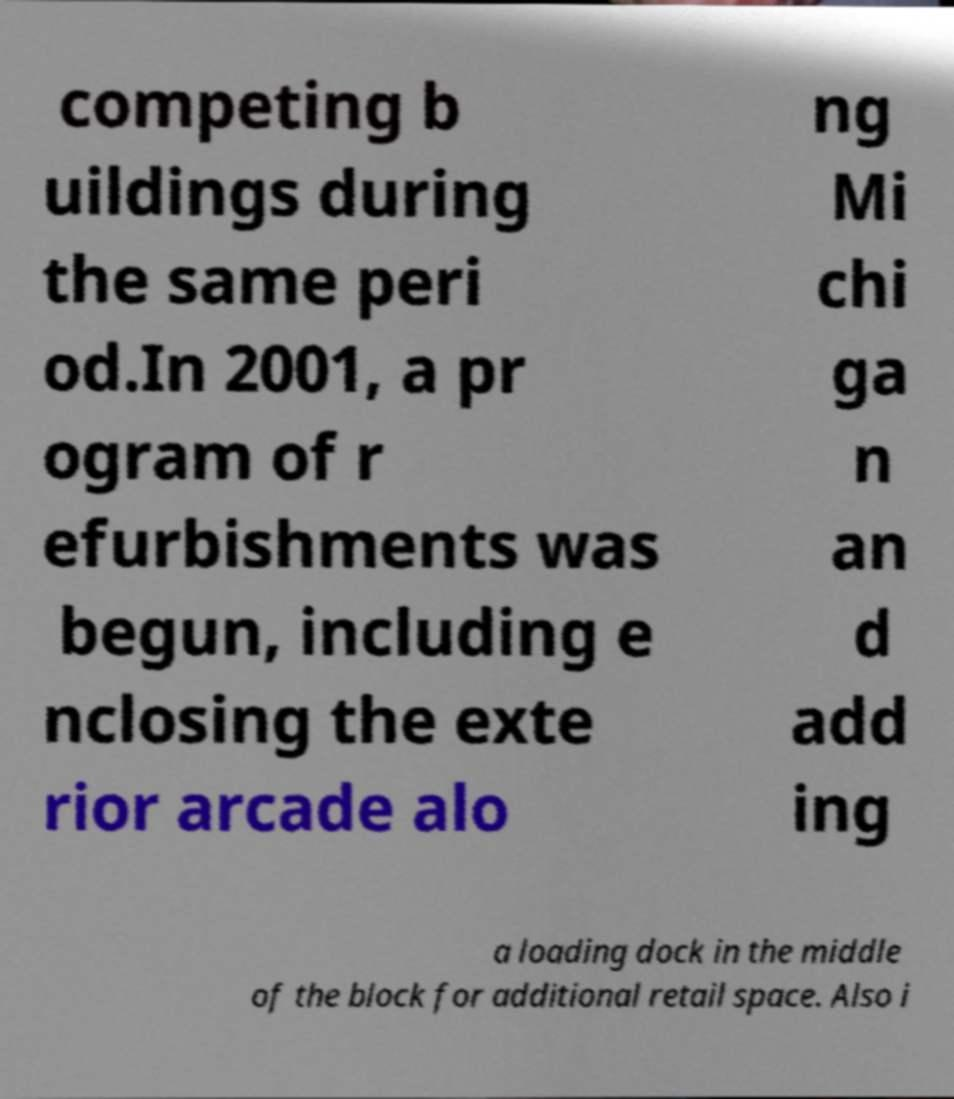Can you accurately transcribe the text from the provided image for me? competing b uildings during the same peri od.In 2001, a pr ogram of r efurbishments was begun, including e nclosing the exte rior arcade alo ng Mi chi ga n an d add ing a loading dock in the middle of the block for additional retail space. Also i 